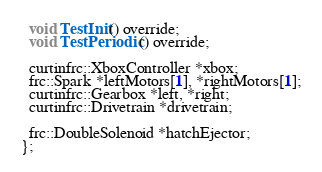Convert code to text. <code><loc_0><loc_0><loc_500><loc_500><_C_>
  void TestInit() override;
  void TestPeriodic() override;

  curtinfrc::XboxController *xbox;
  frc::Spark *leftMotors[1], *rightMotors[1];
  curtinfrc::Gearbox *left, *right;
  curtinfrc::Drivetrain *drivetrain;

  frc::DoubleSolenoid *hatchEjector;
};
</code> 